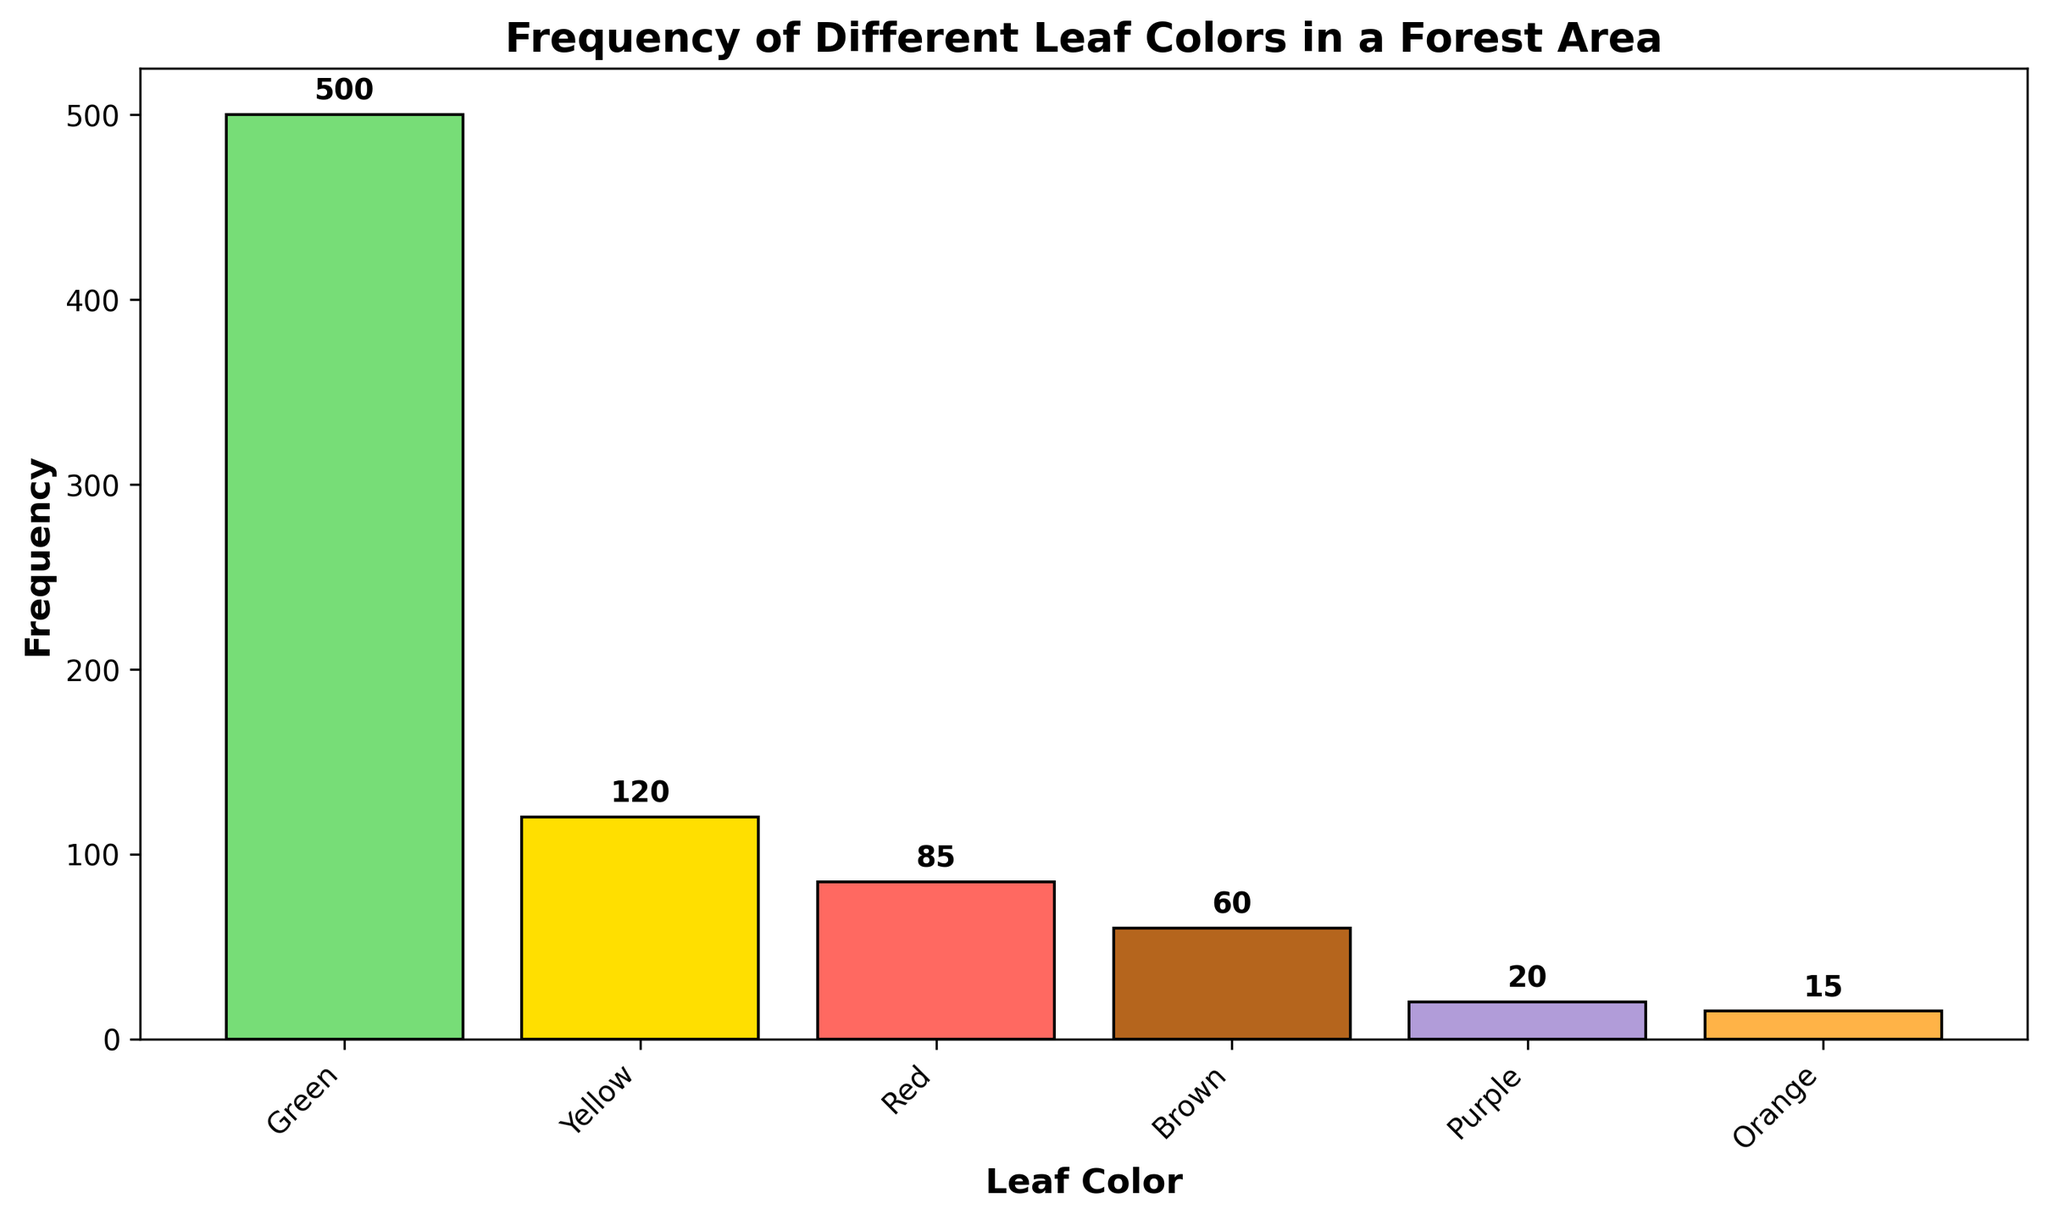What is the most common leaf color in the forest area? Observing the heights of the bars in the histogram, the "Green" bar is the tallest. This indicates that green leaf color has the highest frequency.
Answer: Green Which leaf color has the lowest frequency? By looking at the heights of the bars, the "Orange" bar is the shortest. This indicates that orange leaf color has the lowest frequency.
Answer: Orange How many leaf colors have frequencies above 100? Observing the bars, "Green" and "Yellow" have heights that translate into frequencies above 100.
Answer: 2 What is the difference in frequency between the most common and the least common leaf color? The most common leaf color, green, has a frequency of 500, and the least common, orange, has a frequency of 15. Subtracting these, 500 - 15, gives a difference of 485.
Answer: 485 Which color has a higher frequency: Red or Brown? By comparing the heights of the "Red" and "Brown" bars, "Red" is taller with a frequency of 85, while "Brown" has 60.
Answer: Red What is the sum of the frequencies of the non-green leaf colors? Adding up the frequencies of Yellow (120), Red (85), Brown (60), Purple (20), and Orange (15), we get 120 + 85 + 60 + 20 + 15 = 300.
Answer: 300 How many leaf colors have frequencies below 50? Observing the bars, “Purple” and “Orange” have frequencies below 50.
Answer: 2 What is the ratio of green leaf frequency to the total leaf frequencies? The total frequency is the sum of all leaf colors: 500 (Green) + 120 (Yellow) + 85 (Red) + 60 (Brown) + 20 (Purple) + 15 (Orange) = 800. The ratio is 500/800, which simplifies to 5/8.
Answer: 5/8 What is the average frequency of all leaf colors? Summing all frequencies: 500 + 120 + 85 + 60 + 20 + 15 = 800, and dividing by the number of leaf colors (6), the average is 800/6, approximately 133.33.
Answer: 133.33 Which two colors combined have a total frequency closest to the frequency of the yellow leaves? Yellow has a frequency of 120. Adding Red (85) and Brown (60), we get 85 + 60 = 145, which is the closest sum.
Answer: Red and Brown 